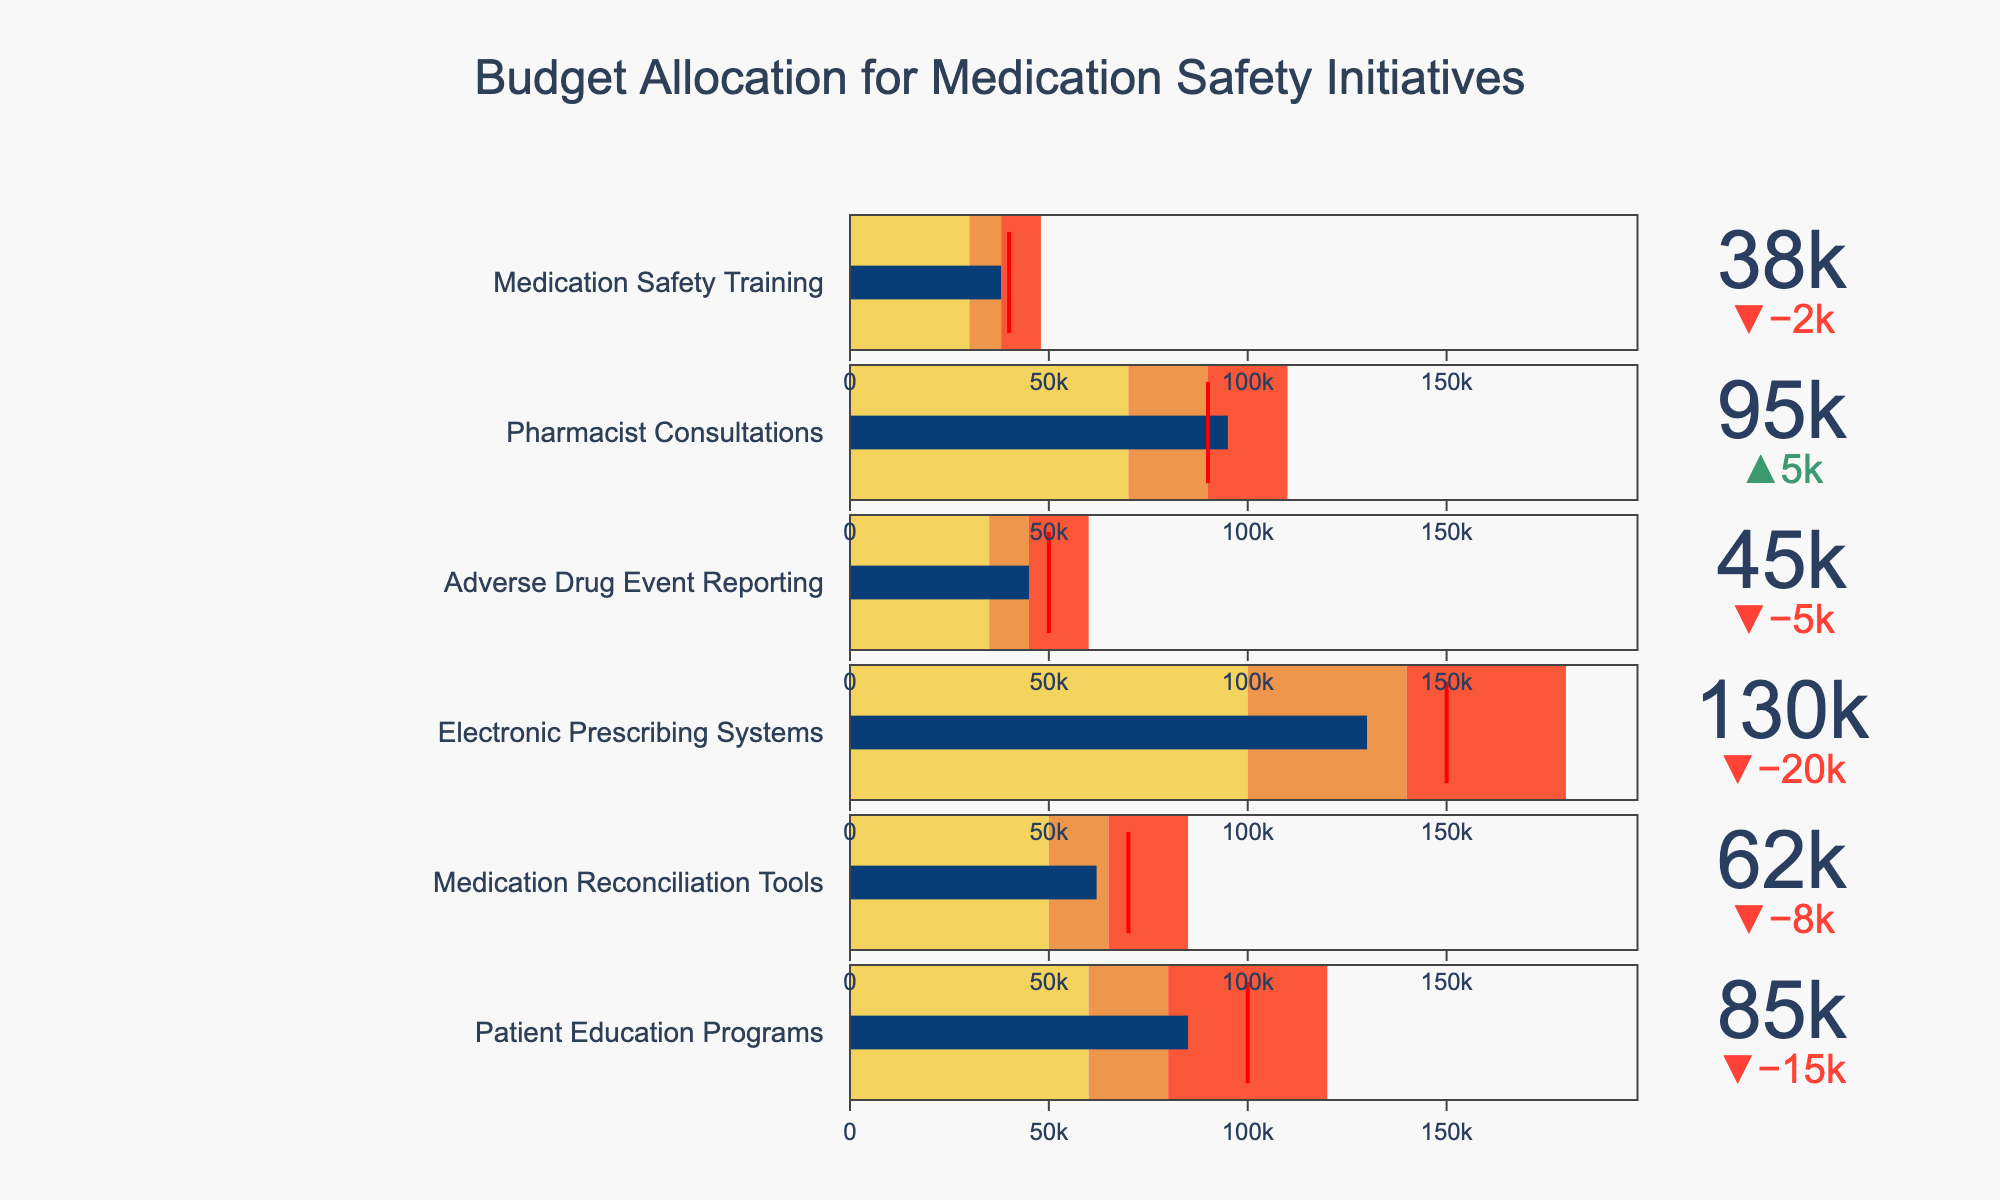What is the total budget allocated to Patient Education Programs? The bullet chart for Patient Education Programs shows an actual value of 85,000. This is the total budget allocated to it.
Answer: 85,000 Which category has the highest target expenditure? By observing the value of the target expenditure, Electronic Prescribing Systems have the highest target at 150,000.
Answer: Electronic Prescribing Systems Did any categories exceed their target expenditure? The categories to check for exceeding targets are those whose actual expenditure is greater than the target. Pharmacist Consultations has an actual expenditure of 95,000, which is more than its target of 90,000.
Answer: Pharmacist Consultations How much more is spent on Electronic Prescribing Systems than Medication Reconciliation Tools? To find the difference, subtract the actual expenditure of Medication Reconciliation Tools (62,000) from that of Electronic Prescribing Systems (130,000). 130,000 - 62,000 = 68,000.
Answer: 68,000 What range is considered high for Medication Safety Training? The high range for Medication Safety Training is given as 30,000 to 48,000.
Answer: 30,000 to 48,000 How many categories have an actual value greater than their medium range? Count the number of categories where the actual value is higher than the medium range. These are Electronic Prescribing Systems (130,000), Pharmacist Consultations (95,000), and Patient Education Programs (85,000). There are three categories.
Answer: 3 What is the color representing the low range in the chart? The low range is represented by a different color for lower, medium and high. For the low range, in the legend or key, the color is shown as #F4D35E (Yellow).
Answer: Yellow Which category has the smallest gap between actual and target expenditure? Determine the gap by calculating the absolute difference between actual and target values for each category. For Adverse Drug Event Reporting, the gap is 5000 since 45,000 (actual) is only 5,000 less than 50,000 (target). This gap is the smallest.
Answer: Adverse Drug Event Reporting Considering all categories, what is the overall difference between total actual expenditure and total target expenditure? Sum all actual and target expenditures, then find the difference. (85000 + 62000 + 130000 + 45000 + 95000 + 38000) for actuals gives 455,000 and (100000 + 70000 + 150000 + 50000 + 90000 + 40000) for targets gives 500,000. The difference is 500,000 - 455,000 = 45,000.
Answer: 45,000 